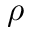Convert formula to latex. <formula><loc_0><loc_0><loc_500><loc_500>\rho</formula> 